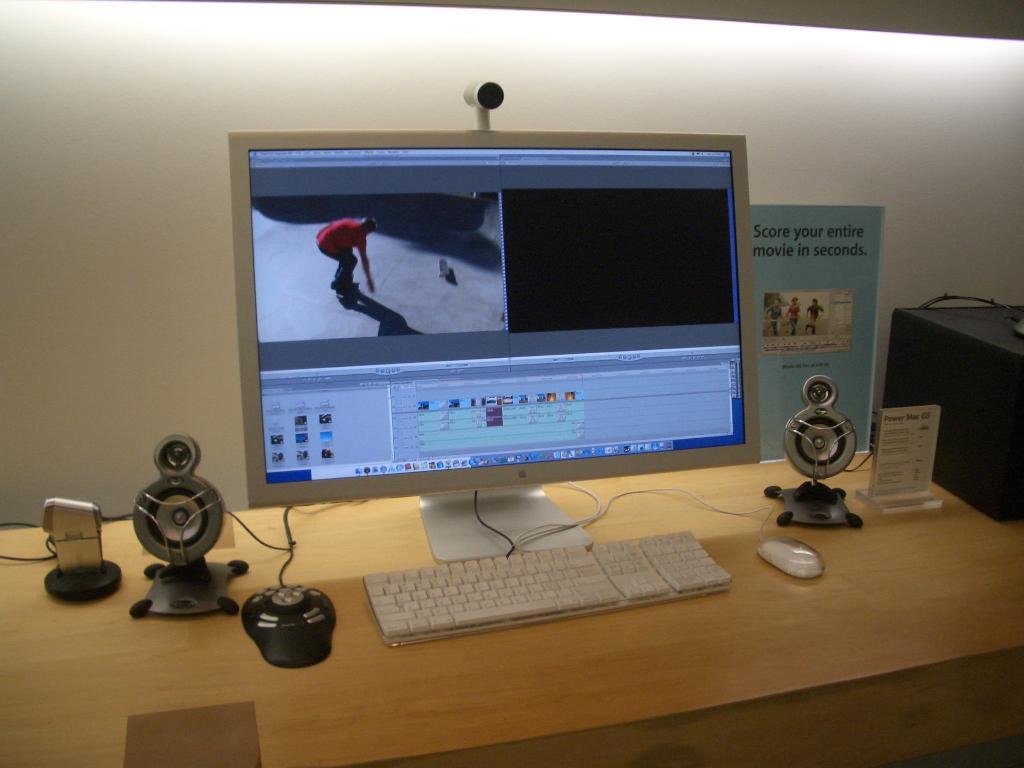How long does it take to score your movie?
Your answer should be compact. Seconds. What can you score in seconds?
Offer a terse response. Entire movie. 